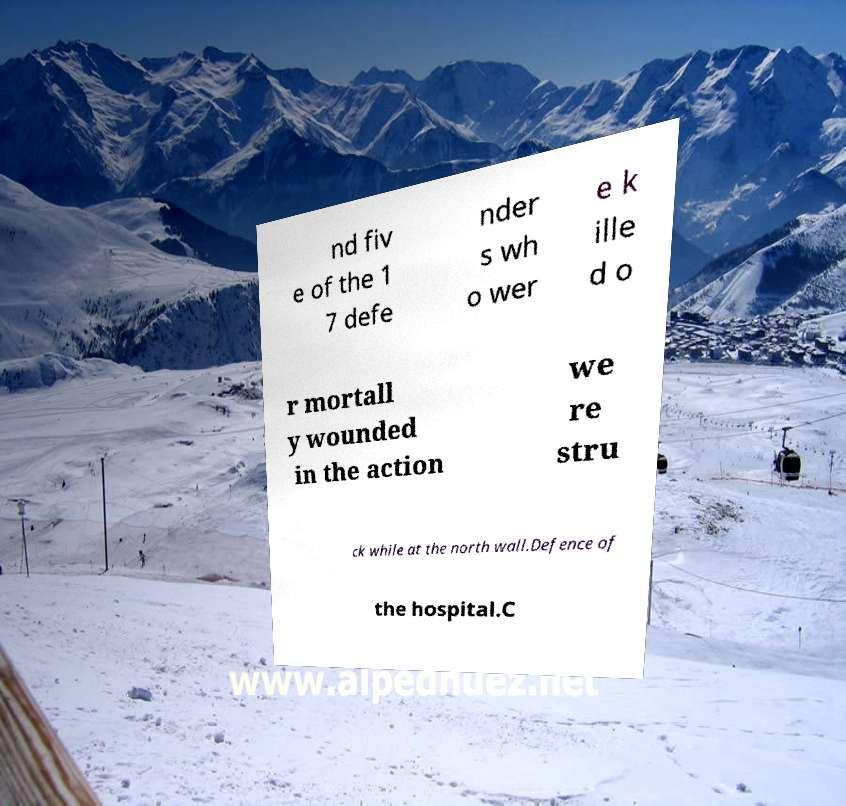Could you assist in decoding the text presented in this image and type it out clearly? nd fiv e of the 1 7 defe nder s wh o wer e k ille d o r mortall y wounded in the action we re stru ck while at the north wall.Defence of the hospital.C 